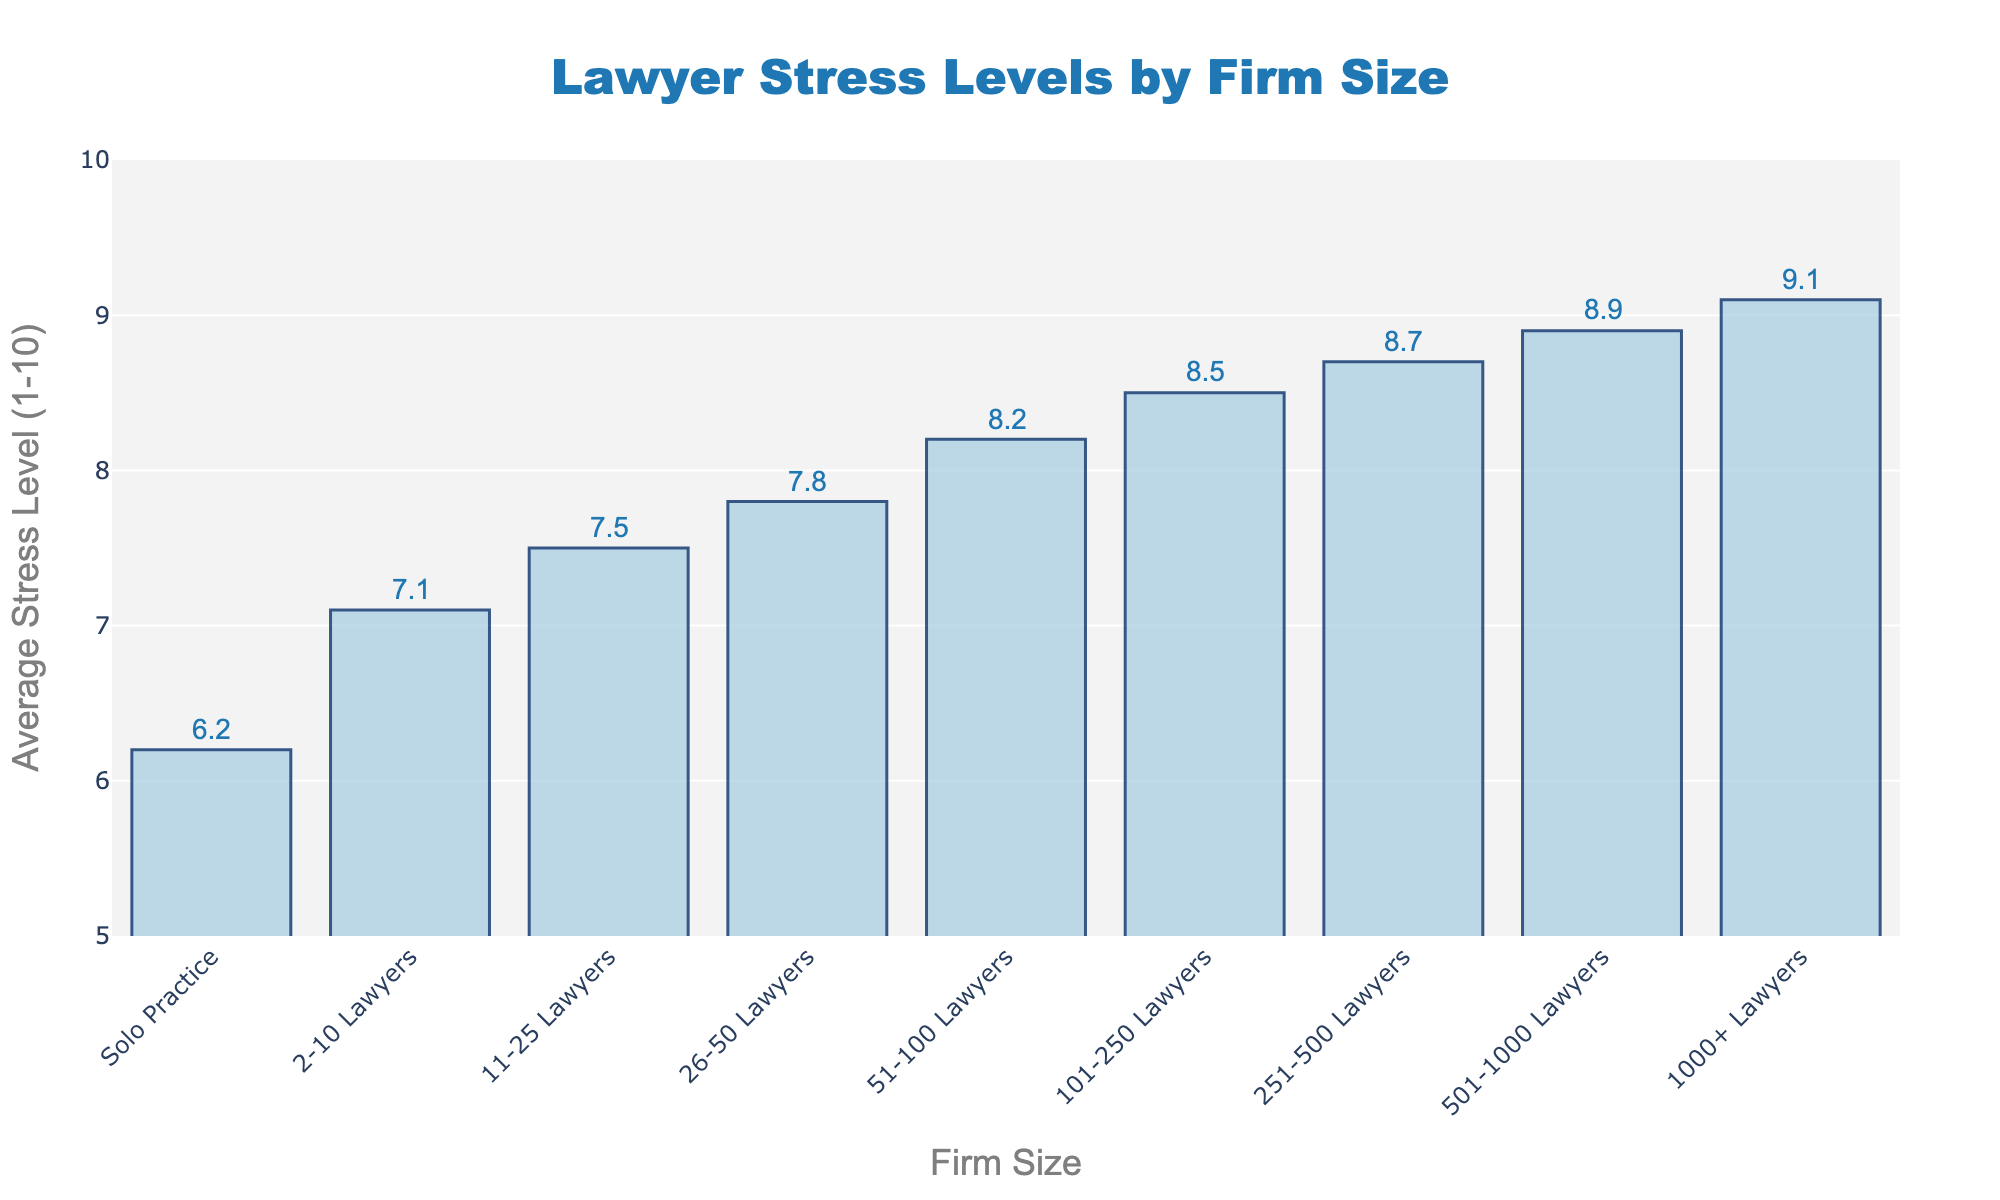What is the average stress level for lawyers in firms with 1000+ lawyers? To find the average stress level for lawyers in firms with 1000+ lawyers, refer to the corresponding bar in the bar chart. The figure explicitly states the value.
Answer: 9.1 Which firm size has the highest reported average stress level? By visually inspecting the chart, identify the bar that is the tallest, as this corresponds to the highest average stress level reported.
Answer: 1000+ Lawyers How much higher is the average stress level for firms with 101-250 lawyers compared to solo practice? Compare the heights of the bars for 101-250 Lawyers and Solo Practice. Subtract the stress level for Solo Practice from that of the 101-250 Lawyers firm.
Answer: 2.3 Is the average stress level for firms with 2-10 lawyers lower than that for firms with 26-50 lawyers? Compare the heights of the bars for 2-10 Lawyers and 26-50 Lawyers. The bar for 2-10 Lawyers is shorter.
Answer: Yes What is the average stress level for firms with 251-500 lawyers? Look at the corresponding bar for 251-500 Lawyers in the chart. The figure explicitly states the value.
Answer: 8.7 By how much does the average stress level increase when comparing firms with 501-1000 lawyers with firms with 51-100 lawyers? Compare the heights of the bars for 501-1000 Lawyers and 51-100 Lawyers. Subtract the stress level for 51-100 Lawyers from that of 501-1000 Lawyers.
Answer: 0.7 What is the range of average stress levels reported across all firm sizes? Identify the minimum and maximum average stress levels in the chart. Subtract the minimum value from the maximum value.
Answer: 2.9 Is the average stress level for firms with 11-25 lawyers closer to that of firms with 2-10 lawyers or firms with 26-50 lawyers? Calculate the absolute difference between the average stress level of 11-25 Lawyers with that of 2-10 Lawyers, and then with that of 26-50 Lawyers. Compare these differences.
Answer: Closer to 26-50 Lawyers Which firm size category shows an average stress level nearly equal to 8.0? Identify the bar with an average stress level closest to 8.0 by visually inspecting the positions of the bars on the y-axis.
Answer: 51-100 Lawyers 